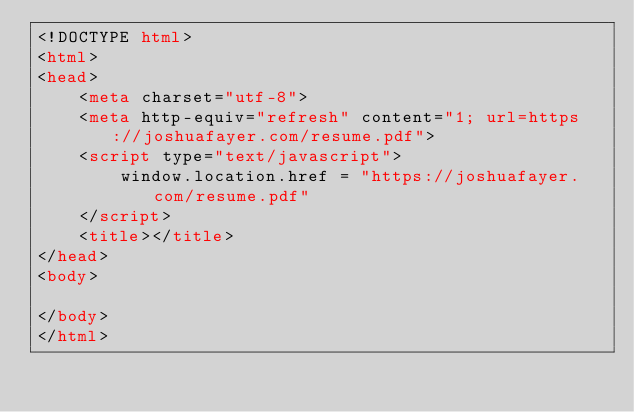Convert code to text. <code><loc_0><loc_0><loc_500><loc_500><_HTML_><!DOCTYPE html>
<html>
<head>
	<meta charset="utf-8">
	<meta http-equiv="refresh" content="1; url=https://joshuafayer.com/resume.pdf">
	<script type="text/javascript">
		window.location.href = "https://joshuafayer.com/resume.pdf"
	</script>
	<title></title>
</head>
<body>

</body>
</html>
</code> 